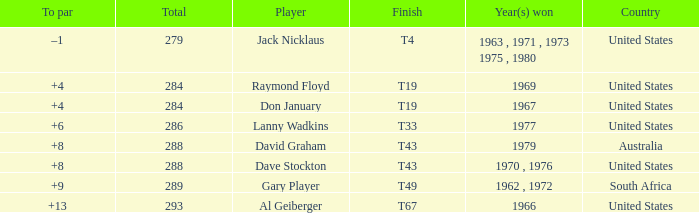What is the average total in 1969? 284.0. 